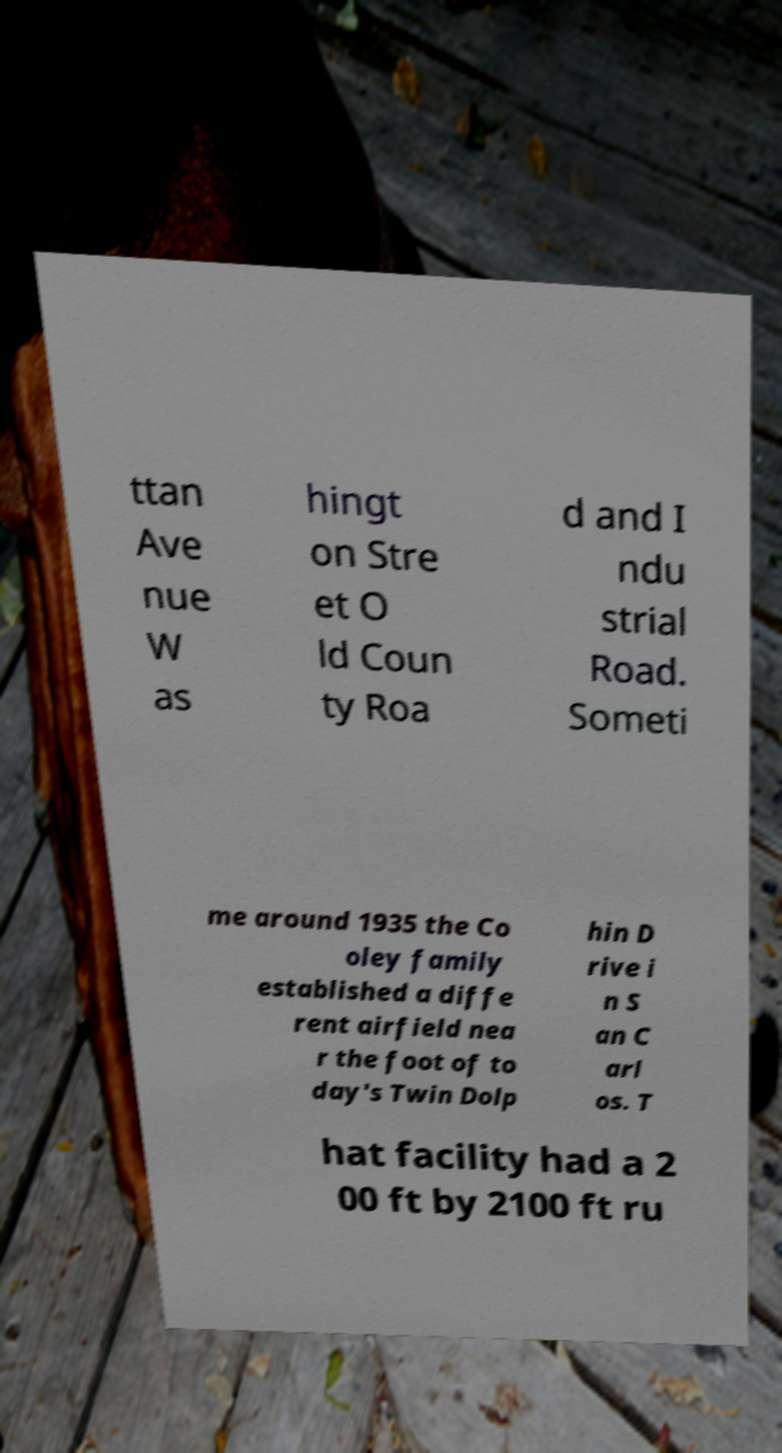Please read and relay the text visible in this image. What does it say? ttan Ave nue W as hingt on Stre et O ld Coun ty Roa d and I ndu strial Road. Someti me around 1935 the Co oley family established a diffe rent airfield nea r the foot of to day's Twin Dolp hin D rive i n S an C arl os. T hat facility had a 2 00 ft by 2100 ft ru 